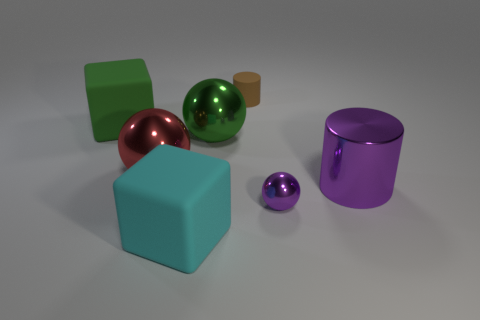Add 1 small objects. How many objects exist? 8 Subtract all blocks. How many objects are left? 5 Subtract all tiny brown cylinders. Subtract all red shiny balls. How many objects are left? 5 Add 1 red things. How many red things are left? 2 Add 1 large metallic cylinders. How many large metallic cylinders exist? 2 Subtract 1 brown cylinders. How many objects are left? 6 